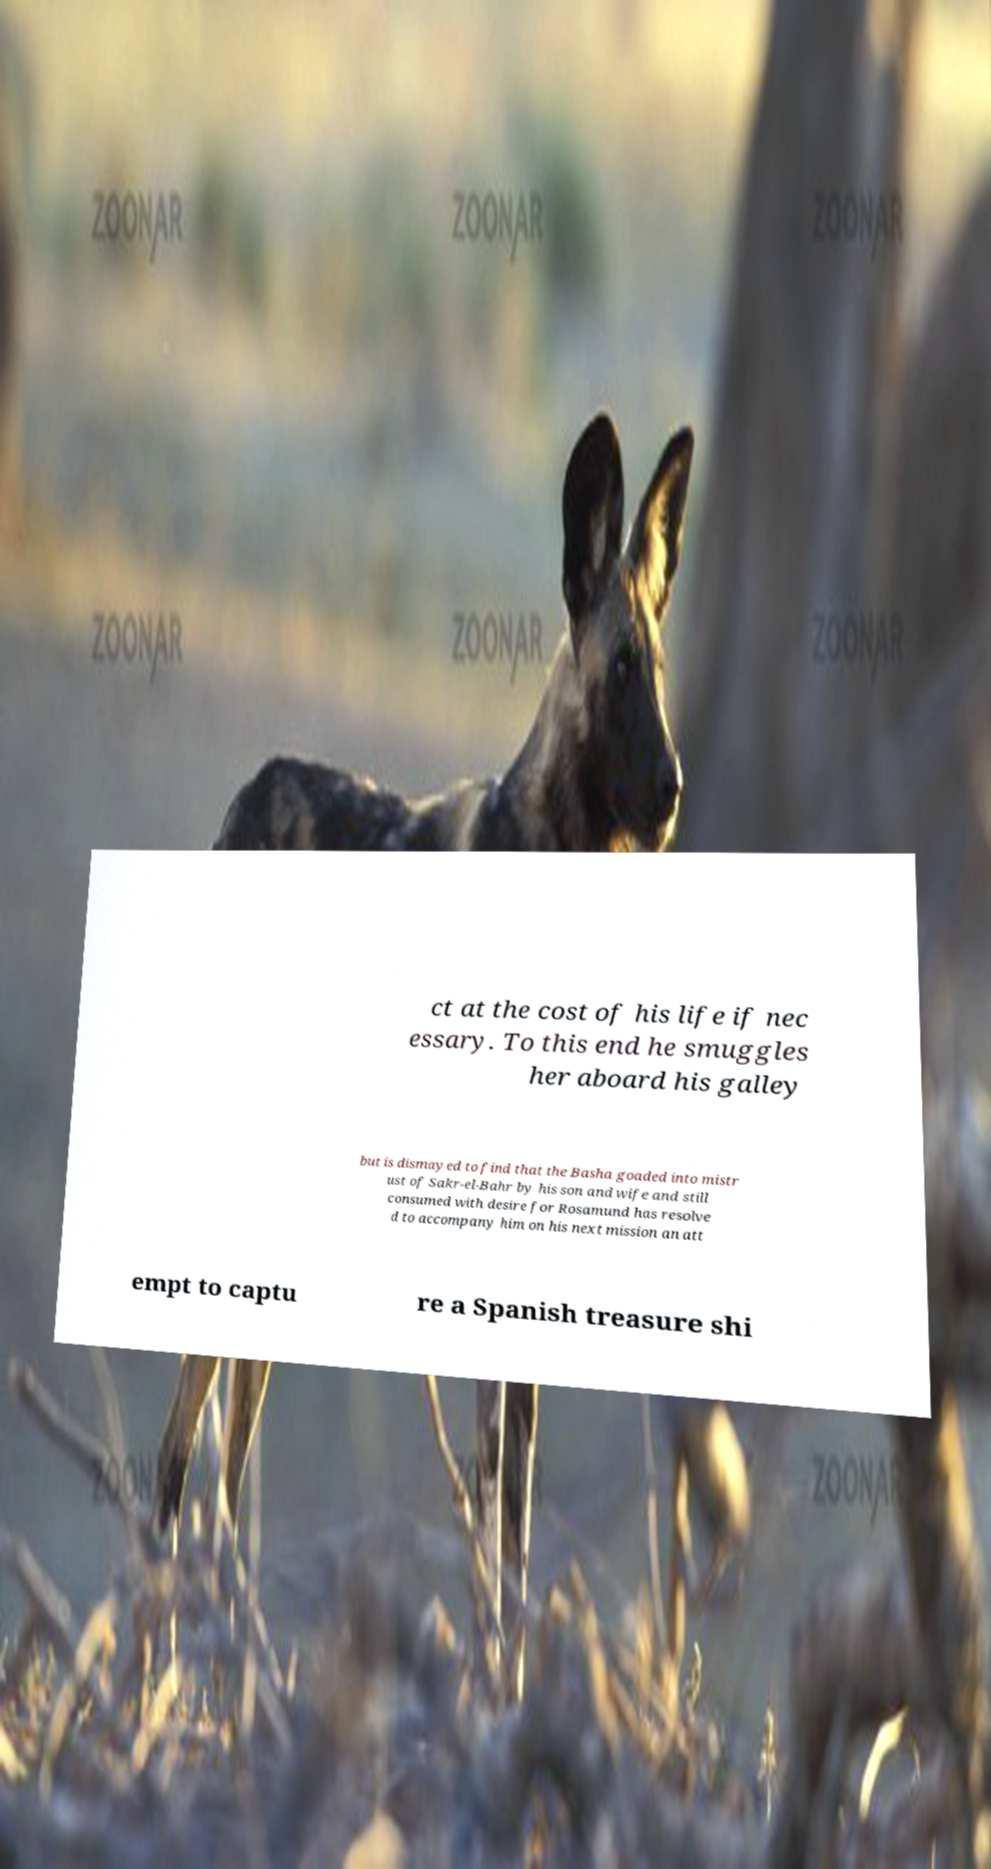Can you accurately transcribe the text from the provided image for me? ct at the cost of his life if nec essary. To this end he smuggles her aboard his galley but is dismayed to find that the Basha goaded into mistr ust of Sakr-el-Bahr by his son and wife and still consumed with desire for Rosamund has resolve d to accompany him on his next mission an att empt to captu re a Spanish treasure shi 